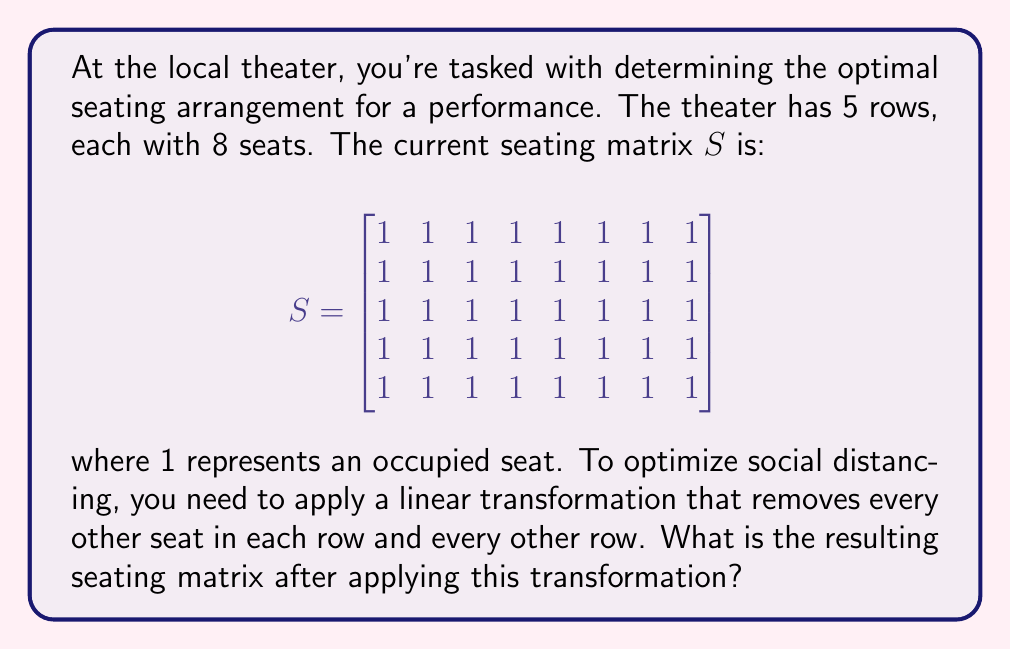Solve this math problem. Let's approach this step-by-step:

1) First, we need to create a transformation matrix that will remove every other seat in each row. This can be represented by:

   $$T_1 = \begin{bmatrix}
   1 & 0 & 0 & 0 & 0 & 0 & 0 & 0 \\
   0 & 0 & 1 & 0 & 0 & 0 & 0 & 0 \\
   0 & 0 & 0 & 0 & 1 & 0 & 0 & 0 \\
   0 & 0 & 0 & 0 & 0 & 0 & 1 & 0
   \end{bmatrix}$$

2) Applying this transformation to S:

   $$S_1 = S \cdot T_1 = \begin{bmatrix}
   1 & 0 & 1 & 0 & 1 & 0 & 1 & 0 \\
   1 & 0 & 1 & 0 & 1 & 0 & 1 & 0 \\
   1 & 0 & 1 & 0 & 1 & 0 & 1 & 0 \\
   1 & 0 & 1 & 0 & 1 & 0 & 1 & 0 \\
   1 & 0 & 1 & 0 & 1 & 0 & 1 & 0
   \end{bmatrix}$$

3) Now, we need to remove every other row. We can do this with another transformation:

   $$T_2 = \begin{bmatrix}
   1 & 0 & 0 & 0 & 0 \\
   0 & 0 & 1 & 0 & 0 \\
   0 & 0 & 0 & 0 & 1
   \end{bmatrix}$$

4) Applying this transformation to $S_1$:

   $$S_2 = T_2 \cdot S_1 = \begin{bmatrix}
   1 & 0 & 1 & 0 & 1 & 0 & 1 & 0 \\
   1 & 0 & 1 & 0 & 1 & 0 & 1 & 0 \\
   1 & 0 & 1 & 0 & 1 & 0 & 1 & 0
   \end{bmatrix}$$

This $S_2$ matrix represents the final seating arrangement after applying both transformations.
Answer: $$\begin{bmatrix}
1 & 0 & 1 & 0 & 1 & 0 & 1 & 0 \\
1 & 0 & 1 & 0 & 1 & 0 & 1 & 0 \\
1 & 0 & 1 & 0 & 1 & 0 & 1 & 0
\end{bmatrix}$$ 